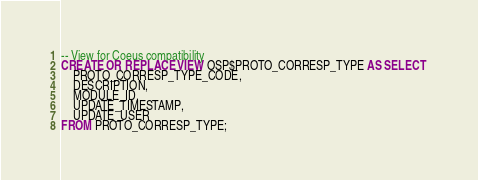Convert code to text. <code><loc_0><loc_0><loc_500><loc_500><_SQL_>-- View for Coeus compatibility 
CREATE OR REPLACE VIEW OSP$PROTO_CORRESP_TYPE AS SELECT 
    PROTO_CORRESP_TYPE_CODE, 
    DESCRIPTION, 
    MODULE_ID, 
    UPDATE_TIMESTAMP, 
    UPDATE_USER
FROM PROTO_CORRESP_TYPE;
</code> 